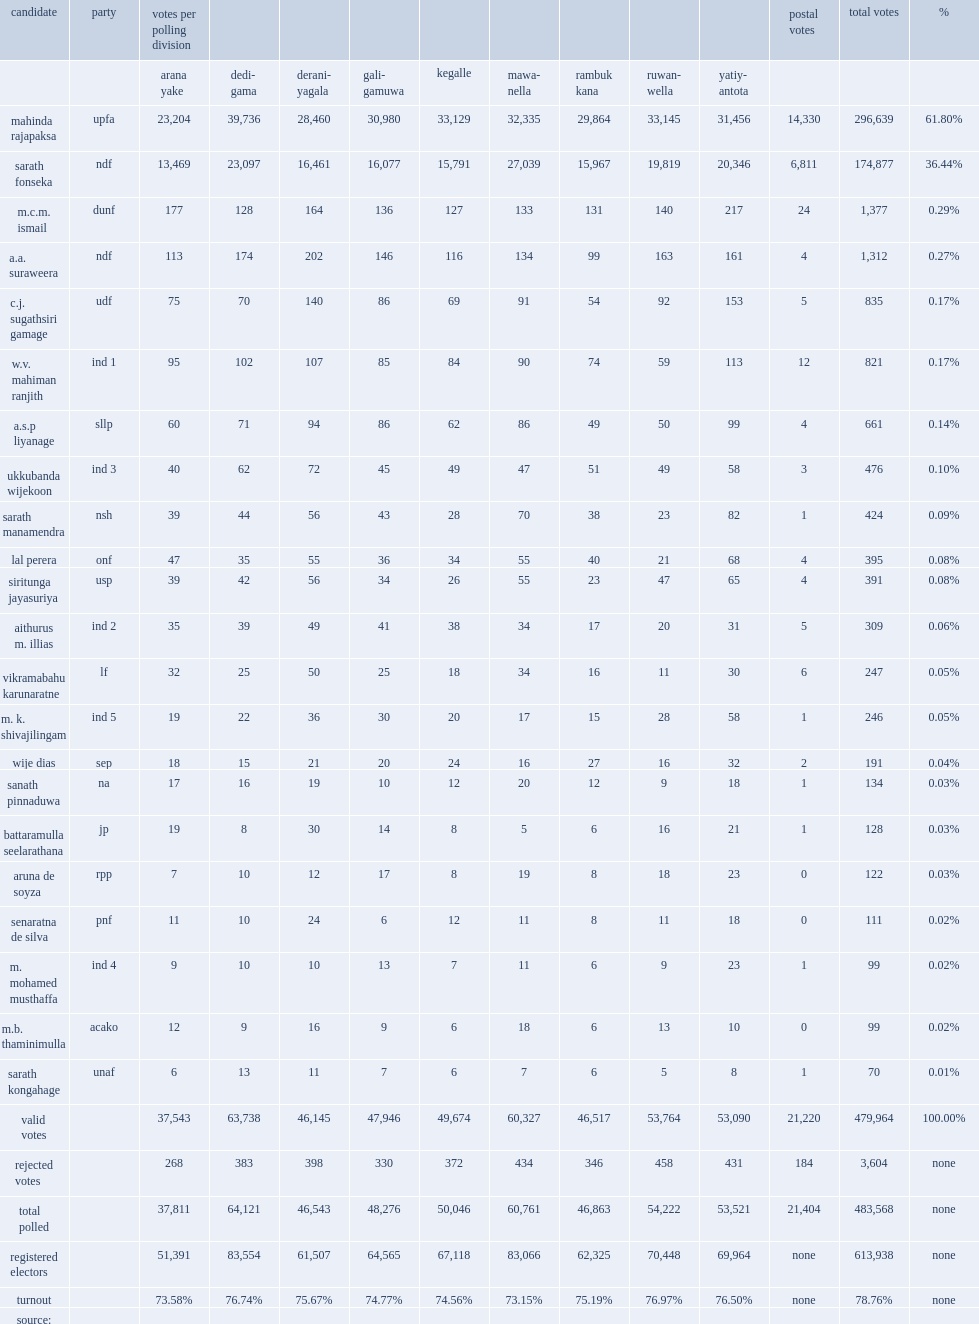How many registered electors are in the kegalle electoral district in 2010? 613938.0. 